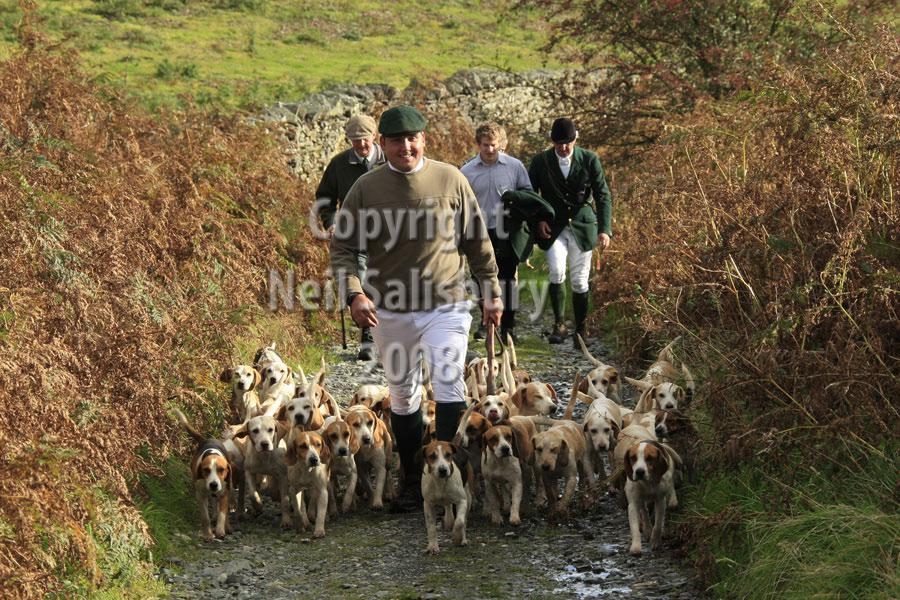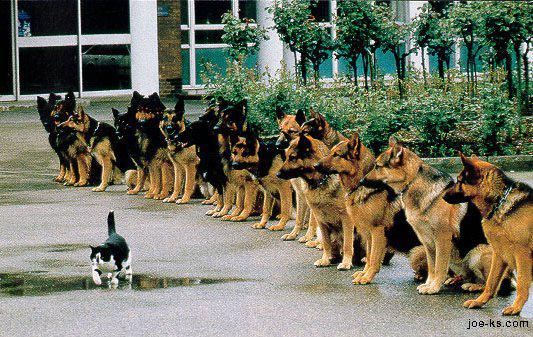The first image is the image on the left, the second image is the image on the right. For the images displayed, is the sentence "An image shows a horizontal row of beagle hounds, with no humans present." factually correct? Answer yes or no. No. The first image is the image on the left, the second image is the image on the right. Given the left and right images, does the statement "The dogs in the left image are walking toward the camera in a large group." hold true? Answer yes or no. Yes. 